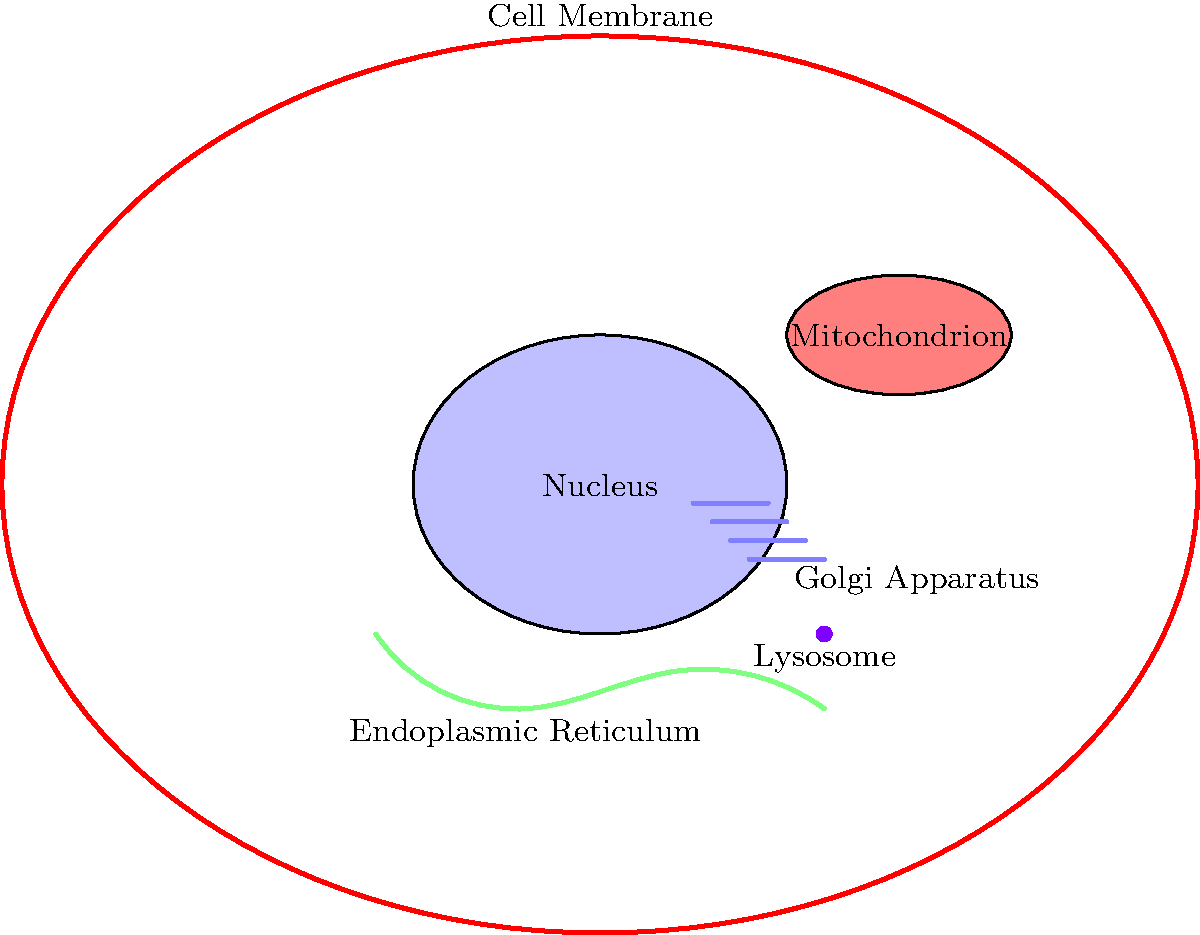As a nurse with a strong foundation in modern science, identify the organelle primarily responsible for energy production in a human cell. To answer this question, let's consider the main functions of each labeled organelle in the human cell:

1. Nucleus: Contains genetic material (DNA) and controls cellular activities.
2. Endoplasmic Reticulum: Synthesizes and transports proteins and lipids.
3. Golgi Apparatus: Modifies, packages, and distributes cellular products.
4. Lysosome: Breaks down cellular waste and foreign materials.
5. Cell Membrane: Controls what enters and exits the cell.
6. Mitochondrion: Produces energy through cellular respiration.

Among these organelles, the mitochondrion is specifically designed for energy production. It is often referred to as the "powerhouse" of the cell because it generates most of the cell's supply of adenosine triphosphate (ATP), which is used as a source of chemical energy.

The mitochondrion achieves this through the process of cellular respiration, which involves:
1. Glycolysis in the cytoplasm
2. The citric acid cycle
3. The electron transport chain and oxidative phosphorylation

These processes efficiently convert nutrients into ATP, providing the energy needed for various cellular functions. This makes the mitochondrion crucial for maintaining cellular health and function, which is particularly important in the context of patient care and understanding cellular processes in medical settings.
Answer: Mitochondrion 